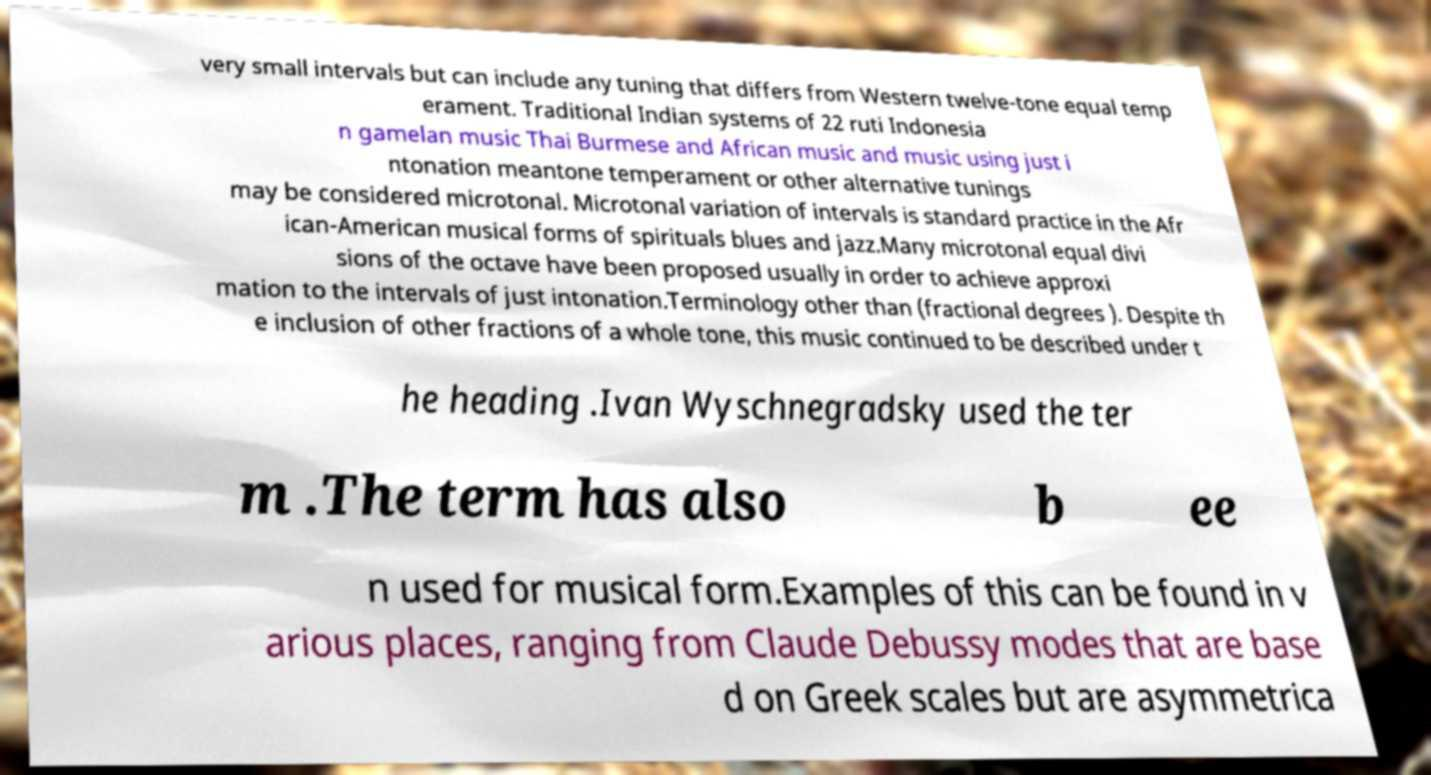Please read and relay the text visible in this image. What does it say? very small intervals but can include any tuning that differs from Western twelve-tone equal temp erament. Traditional Indian systems of 22 ruti Indonesia n gamelan music Thai Burmese and African music and music using just i ntonation meantone temperament or other alternative tunings may be considered microtonal. Microtonal variation of intervals is standard practice in the Afr ican-American musical forms of spirituals blues and jazz.Many microtonal equal divi sions of the octave have been proposed usually in order to achieve approxi mation to the intervals of just intonation.Terminology other than (fractional degrees ). Despite th e inclusion of other fractions of a whole tone, this music continued to be described under t he heading .Ivan Wyschnegradsky used the ter m .The term has also b ee n used for musical form.Examples of this can be found in v arious places, ranging from Claude Debussy modes that are base d on Greek scales but are asymmetrica 